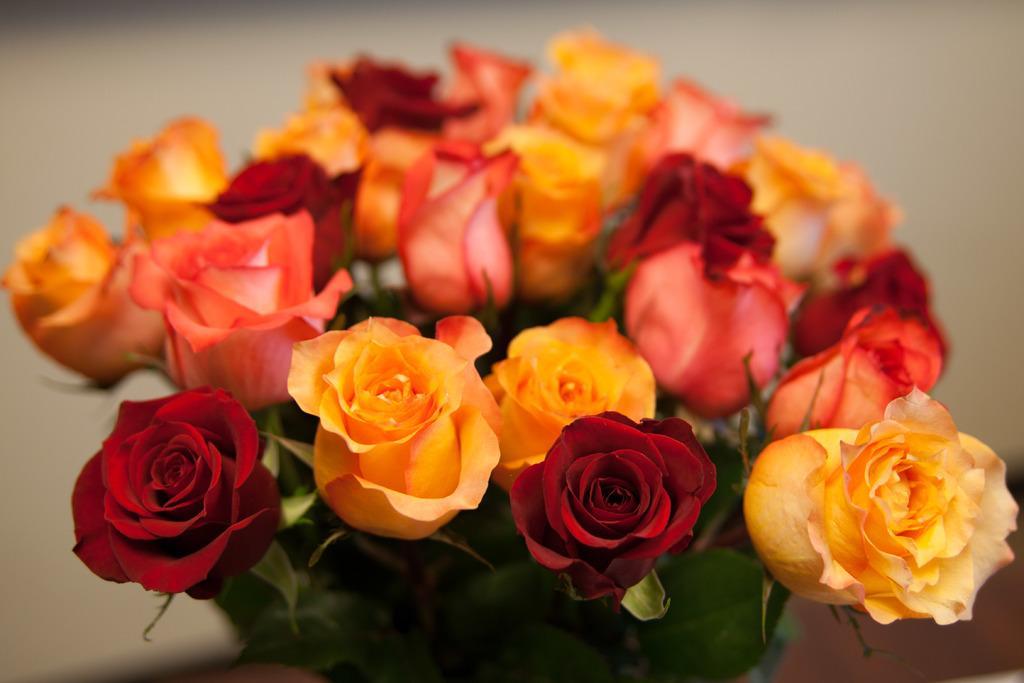How would you summarize this image in a sentence or two? In this image we can see bunch of rose flowers. In the background it is blur. 